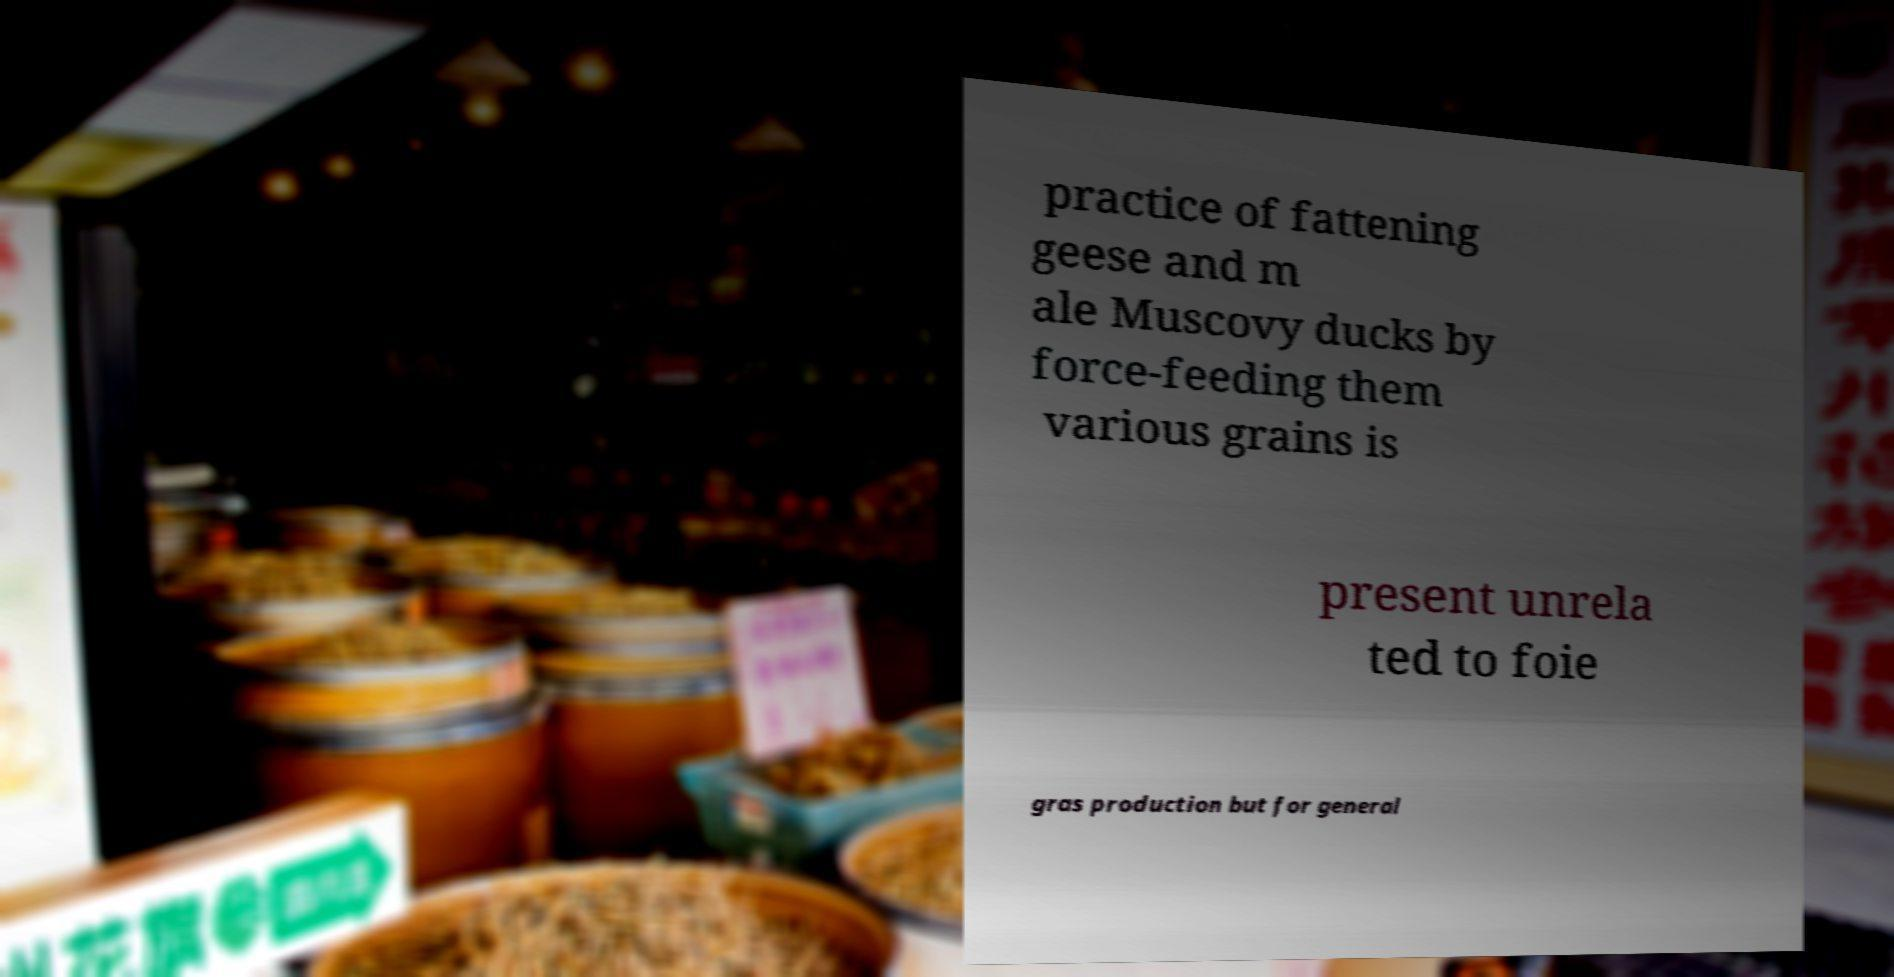Could you extract and type out the text from this image? practice of fattening geese and m ale Muscovy ducks by force-feeding them various grains is present unrela ted to foie gras production but for general 